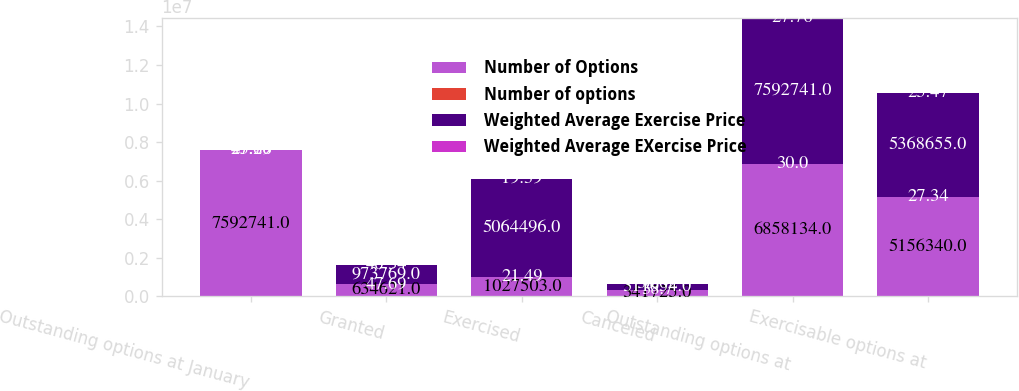<chart> <loc_0><loc_0><loc_500><loc_500><stacked_bar_chart><ecel><fcel>Outstanding options at January<fcel>Granted<fcel>Exercised<fcel>Canceled<fcel>Outstanding options at<fcel>Exercisable options at<nl><fcel>Number of Options<fcel>7.59274e+06<fcel>634621<fcel>1.0275e+06<fcel>341725<fcel>6.85813e+06<fcel>5.15634e+06<nl><fcel>Number of options<fcel>27.76<fcel>47.69<fcel>21.49<fcel>38.7<fcel>30<fcel>27.34<nl><fcel>Weighted Average Exercise Price<fcel>47.69<fcel>973769<fcel>5.0645e+06<fcel>311054<fcel>7.59274e+06<fcel>5.36866e+06<nl><fcel>Weighted Average EXercise Price<fcel>23.28<fcel>40.34<fcel>19.39<fcel>30.02<fcel>27.76<fcel>25.47<nl></chart> 